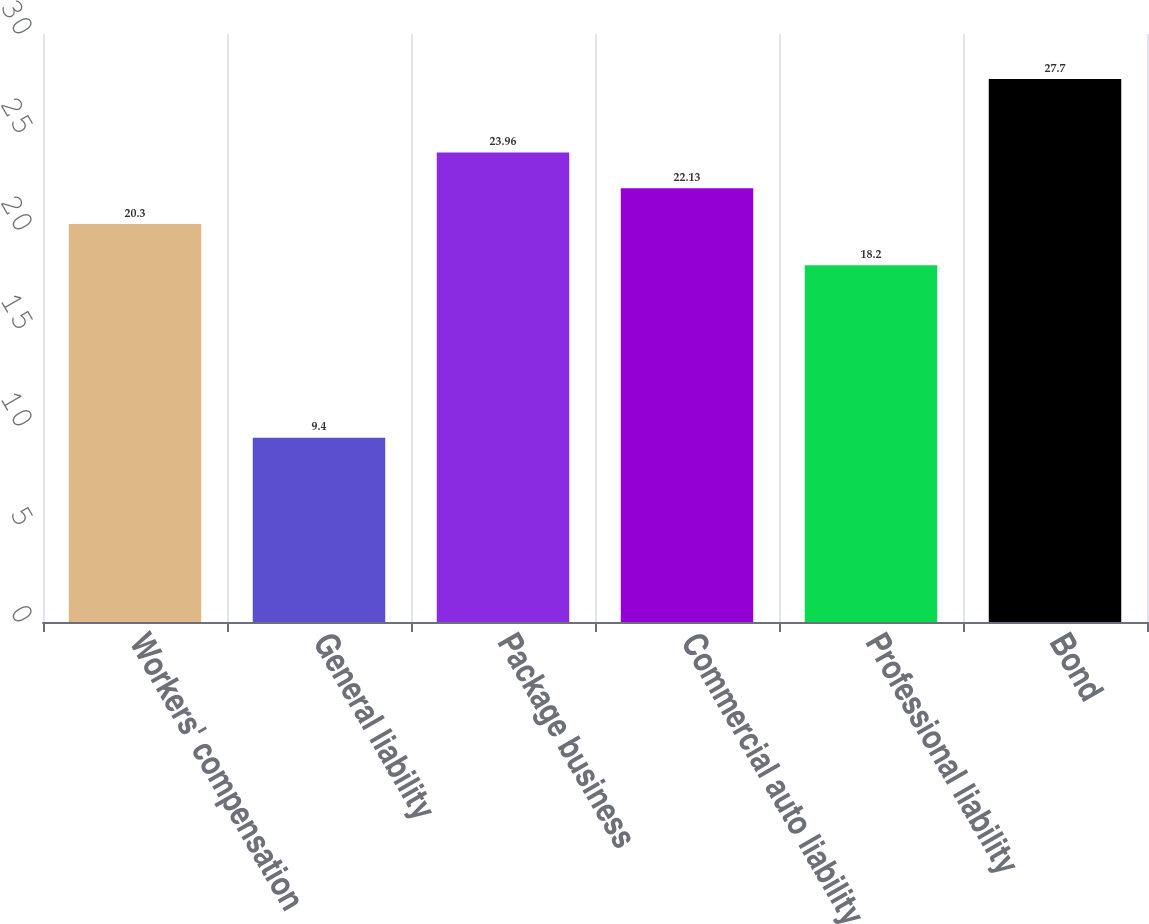<chart> <loc_0><loc_0><loc_500><loc_500><bar_chart><fcel>Workers' compensation<fcel>General liability<fcel>Package business<fcel>Commercial auto liability<fcel>Professional liability<fcel>Bond<nl><fcel>20.3<fcel>9.4<fcel>23.96<fcel>22.13<fcel>18.2<fcel>27.7<nl></chart> 